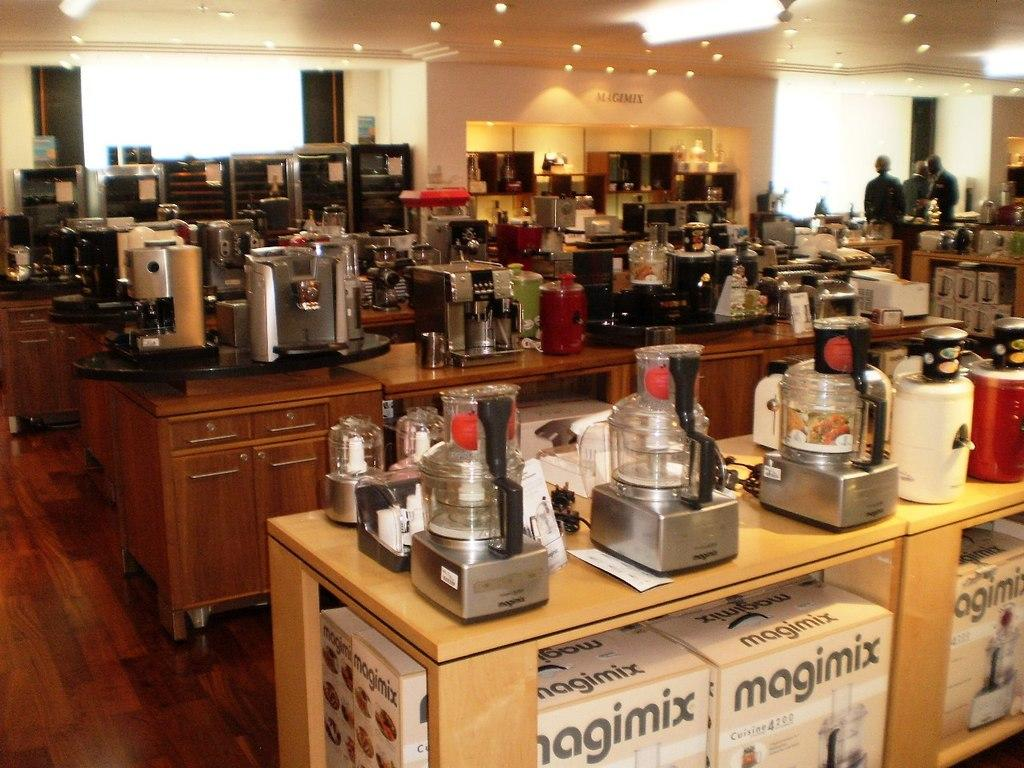<image>
Render a clear and concise summary of the photo. Magimix blenders are arranged on a wooden counter in this store. 